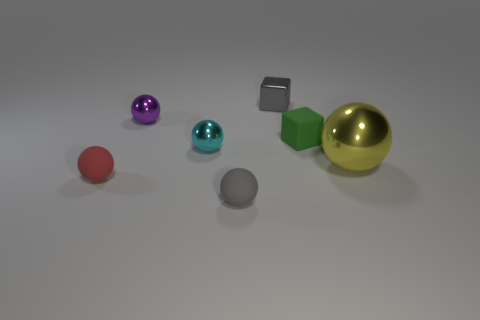The tiny object that is to the right of the cyan shiny sphere and in front of the yellow ball is made of what material?
Your answer should be compact. Rubber. The red rubber ball has what size?
Your answer should be compact. Small. Do the big metallic sphere and the tiny matte object on the left side of the tiny purple ball have the same color?
Give a very brief answer. No. What number of other objects are there of the same color as the tiny metallic block?
Keep it short and to the point. 1. There is a shiny sphere that is in front of the tiny cyan thing; is its size the same as the rubber object behind the large shiny ball?
Your answer should be very brief. No. The metal thing right of the small green thing is what color?
Ensure brevity in your answer.  Yellow. Are there fewer small gray spheres that are behind the tiny cyan metal object than gray spheres?
Provide a short and direct response. Yes. Does the gray cube have the same material as the green thing?
Your answer should be very brief. No. What is the size of the other object that is the same shape as the small gray metallic object?
Your response must be concise. Small. How many objects are spheres that are behind the tiny cyan ball or tiny shiny balls that are left of the small cyan object?
Offer a very short reply. 1. 